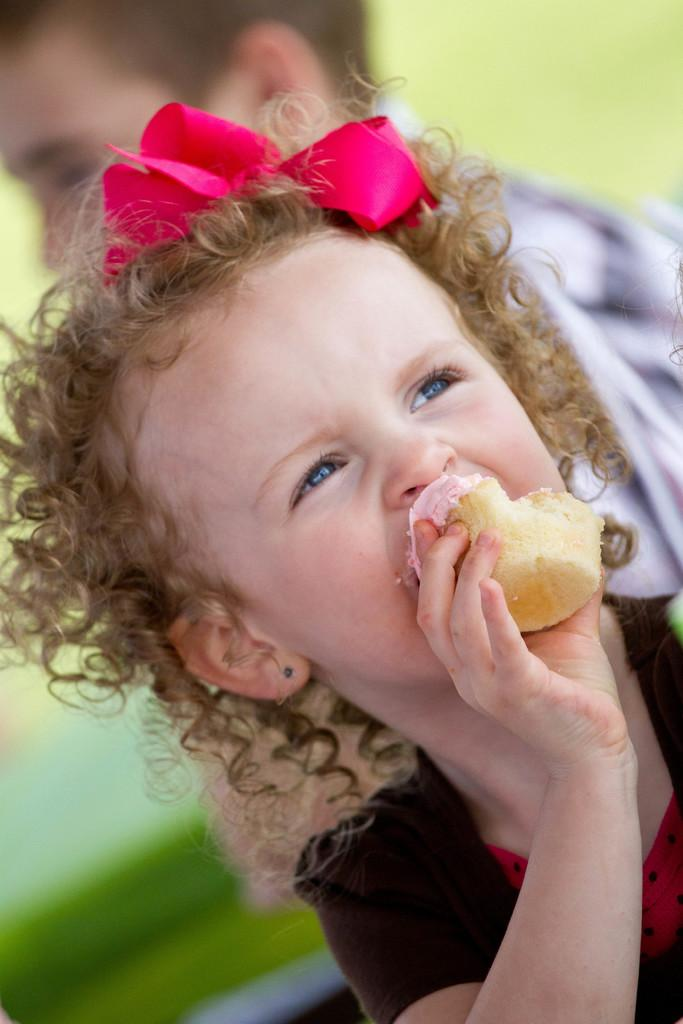Who is the main subject in the image? There is a small girl in the image. What is the girl doing in the image? The girl is eating a cupcake. Are there any other people in the image? Yes, there is a boy in the image. Can you describe the boy's position in relation to the girl? The boy is behind the girl. What type of cave can be seen in the background of the image? There is no cave present in the image; it features a small girl eating a cupcake and a boy standing behind her. 